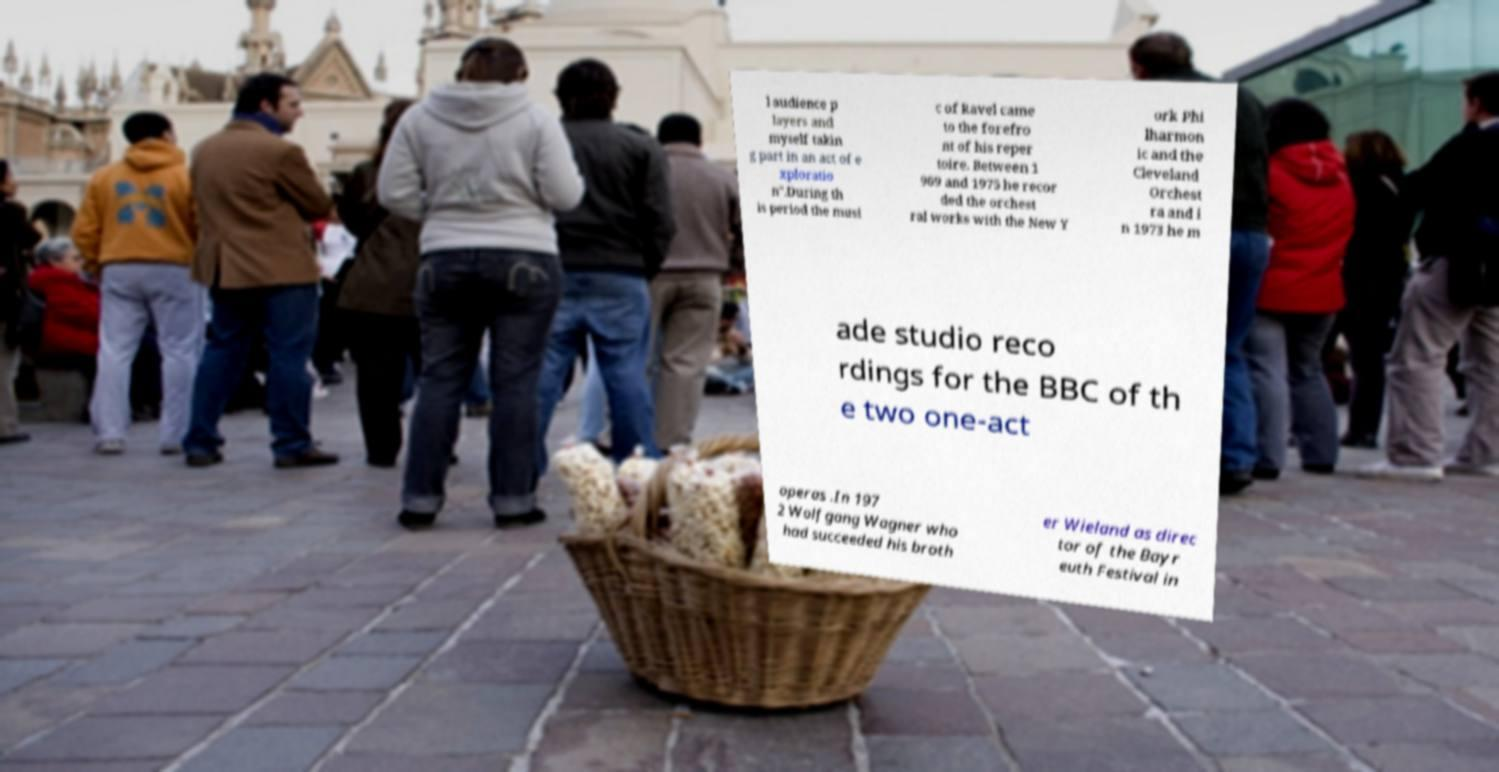What messages or text are displayed in this image? I need them in a readable, typed format. l audience p layers and myself takin g part in an act of e xploratio n".During th is period the musi c of Ravel came to the forefro nt of his reper toire. Between 1 969 and 1975 he recor ded the orchest ral works with the New Y ork Phi lharmon ic and the Cleveland Orchest ra and i n 1973 he m ade studio reco rdings for the BBC of th e two one-act operas .In 197 2 Wolfgang Wagner who had succeeded his broth er Wieland as direc tor of the Bayr euth Festival in 